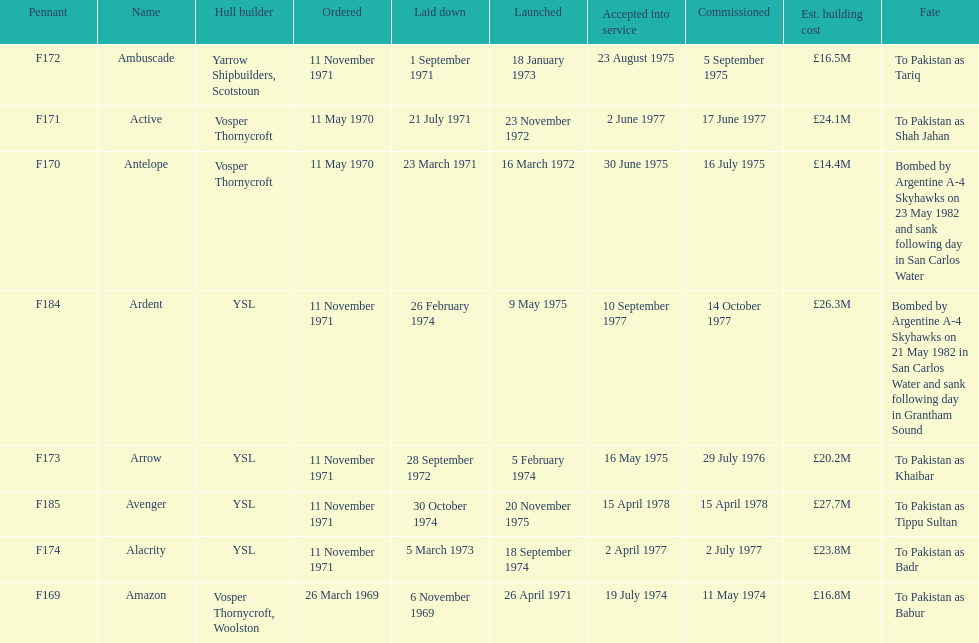How many boats had a construction cost under £20m? 3. 